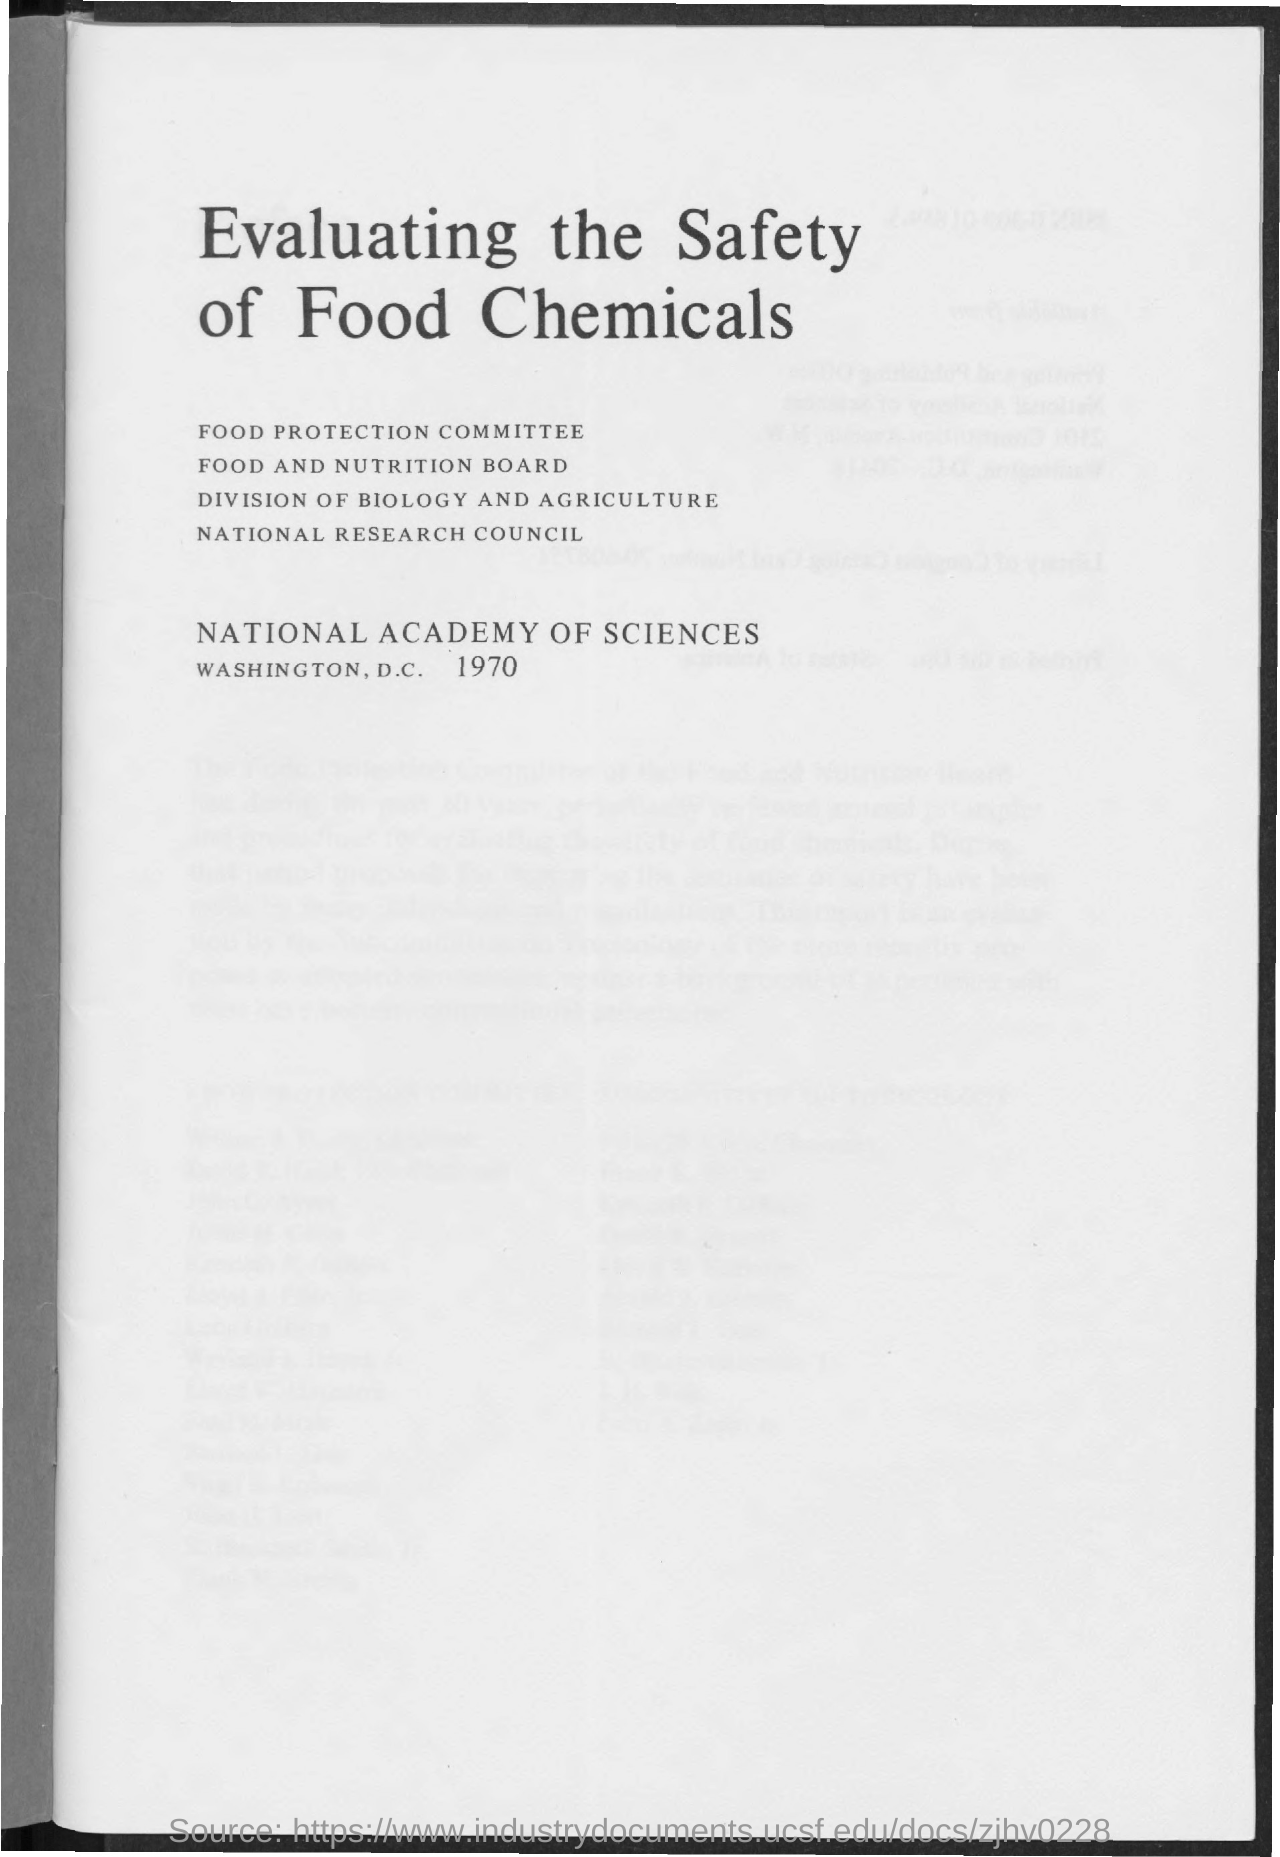What organizations are involved with this document? The organizations mentioned are the Food Protection Committee, Food and Nutrition Board, Division of Biology and Agriculture, and the National Research Council, all of which are part of the National Academy of Sciences based in Washington, D.C. as of 1970. What is the significance of these organizations? These organizations are significant because they collaborate to provide scientific advice on matters related to public health and safety. In this context, they likely contributed their expertise to evaluate and ensure the safe use of chemicals in food. 